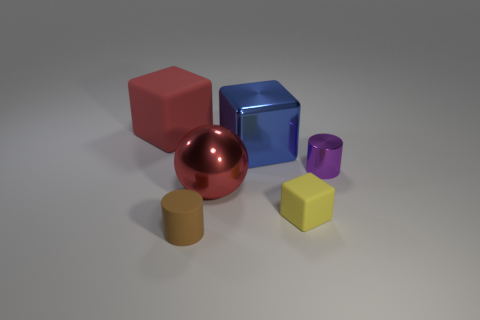What number of other objects are there of the same color as the large rubber cube?
Your answer should be very brief. 1. What material is the large red thing that is to the left of the rubber thing that is in front of the tiny yellow thing?
Offer a very short reply. Rubber. The metallic cylinder is what color?
Provide a short and direct response. Purple. Does the matte cube that is behind the tiny yellow matte cube have the same color as the shiny ball in front of the red matte object?
Your answer should be compact. Yes. What size is the shiny object that is the same shape as the brown matte object?
Provide a short and direct response. Small. Are there any matte cubes of the same color as the big metal sphere?
Provide a short and direct response. Yes. There is a big cube that is the same color as the large metallic ball; what material is it?
Make the answer very short. Rubber. What number of blocks are the same color as the sphere?
Offer a terse response. 1. How many things are either rubber cubes that are behind the red ball or big green metallic objects?
Your response must be concise. 1. The tiny object that is the same material as the ball is what color?
Your response must be concise. Purple. 